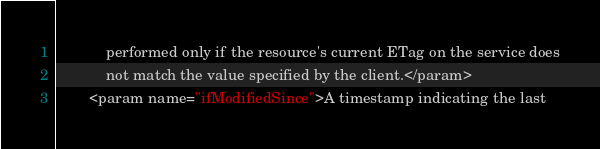<code> <loc_0><loc_0><loc_500><loc_500><_XML_>            performed only if the resource's current ETag on the service does
            not match the value specified by the client.</param>
        <param name="ifModifiedSince">A timestamp indicating the last</code> 